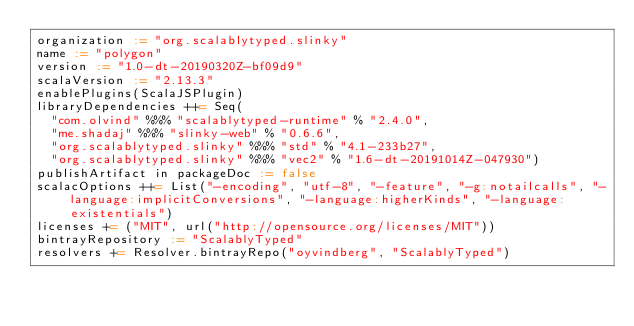<code> <loc_0><loc_0><loc_500><loc_500><_Scala_>organization := "org.scalablytyped.slinky"
name := "polygon"
version := "1.0-dt-20190320Z-bf09d9"
scalaVersion := "2.13.3"
enablePlugins(ScalaJSPlugin)
libraryDependencies ++= Seq(
  "com.olvind" %%% "scalablytyped-runtime" % "2.4.0",
  "me.shadaj" %%% "slinky-web" % "0.6.6",
  "org.scalablytyped.slinky" %%% "std" % "4.1-233b27",
  "org.scalablytyped.slinky" %%% "vec2" % "1.6-dt-20191014Z-047930")
publishArtifact in packageDoc := false
scalacOptions ++= List("-encoding", "utf-8", "-feature", "-g:notailcalls", "-language:implicitConversions", "-language:higherKinds", "-language:existentials")
licenses += ("MIT", url("http://opensource.org/licenses/MIT"))
bintrayRepository := "ScalablyTyped"
resolvers += Resolver.bintrayRepo("oyvindberg", "ScalablyTyped")
</code> 